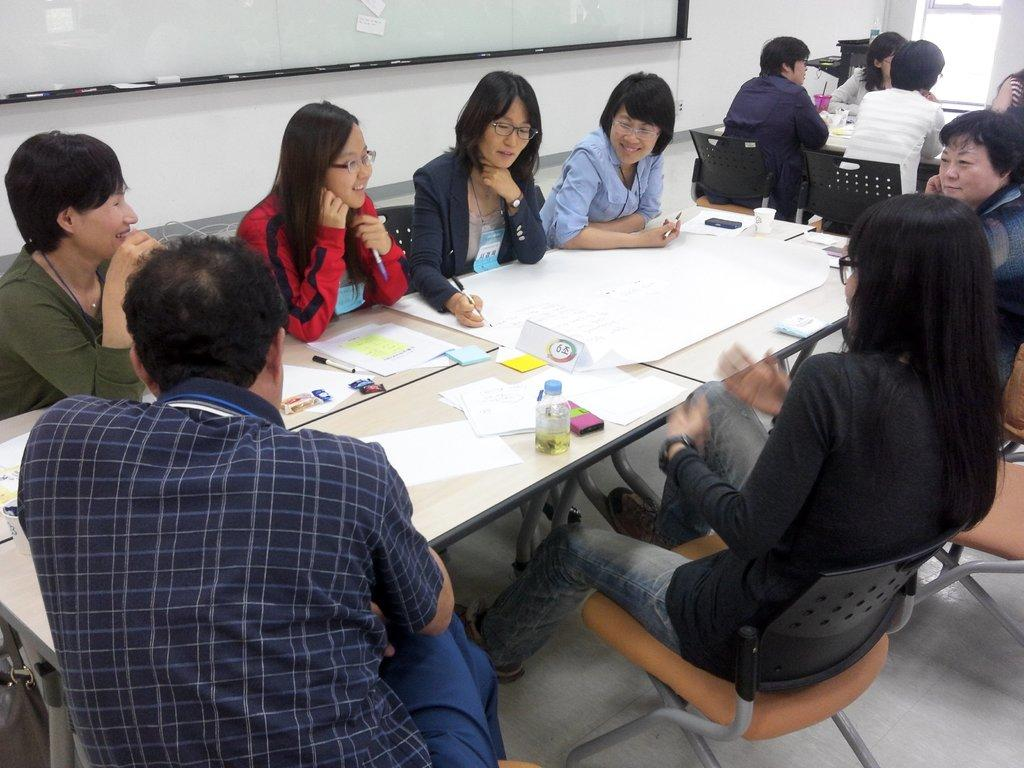What are the people in the image doing? The persons in the image are sitting on chairs. What is on the table in the image? There are papers and a bottle on the table. What is the surface visible beneath the chairs and table? The floor is visible in the image. Is there a chain hanging from the ceiling in the image? There is no chain hanging from the ceiling in the image. What type of root can be seen growing from the floor in the image? There are no roots visible in the image; only chairs, a table, papers, a bottle, and the floor are present. 